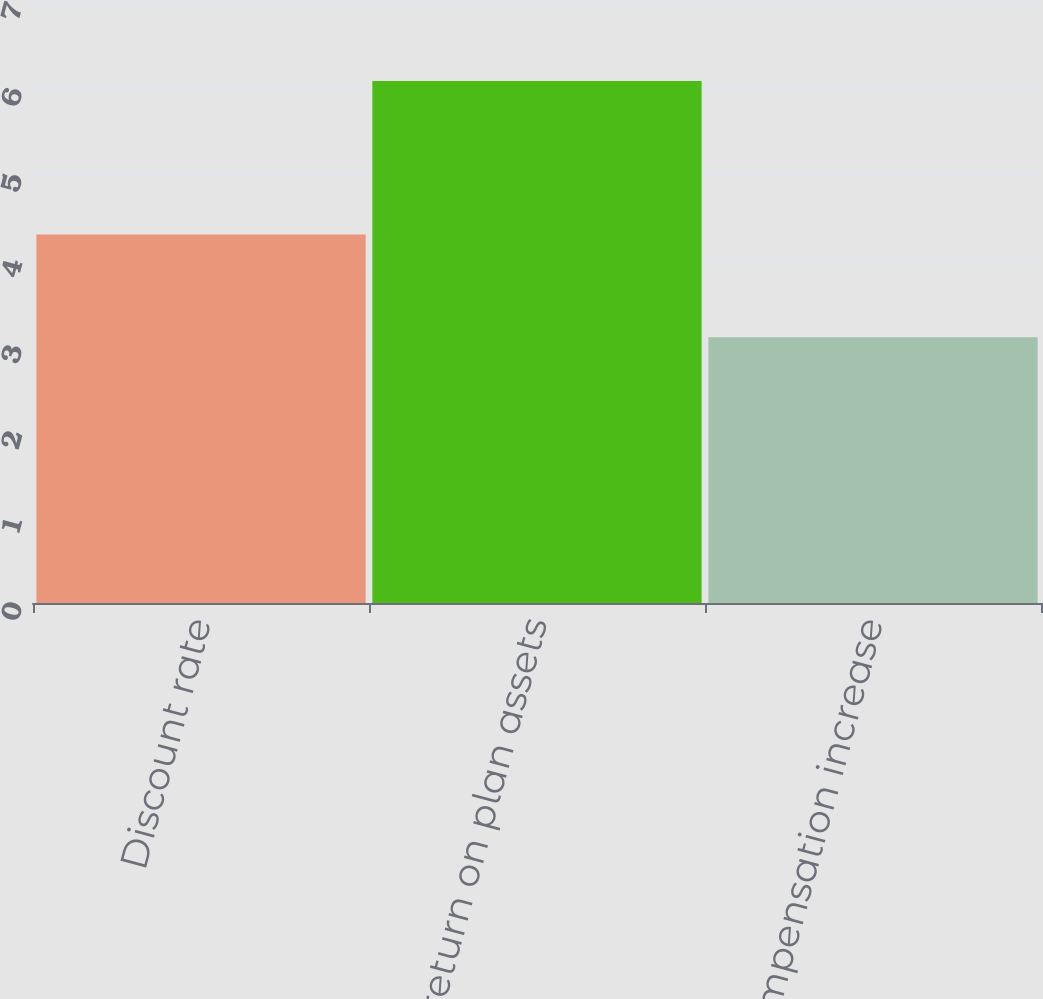Convert chart. <chart><loc_0><loc_0><loc_500><loc_500><bar_chart><fcel>Discount rate<fcel>Expected return on plan assets<fcel>Rate of compensation increase<nl><fcel>4.3<fcel>6.09<fcel>3.1<nl></chart> 